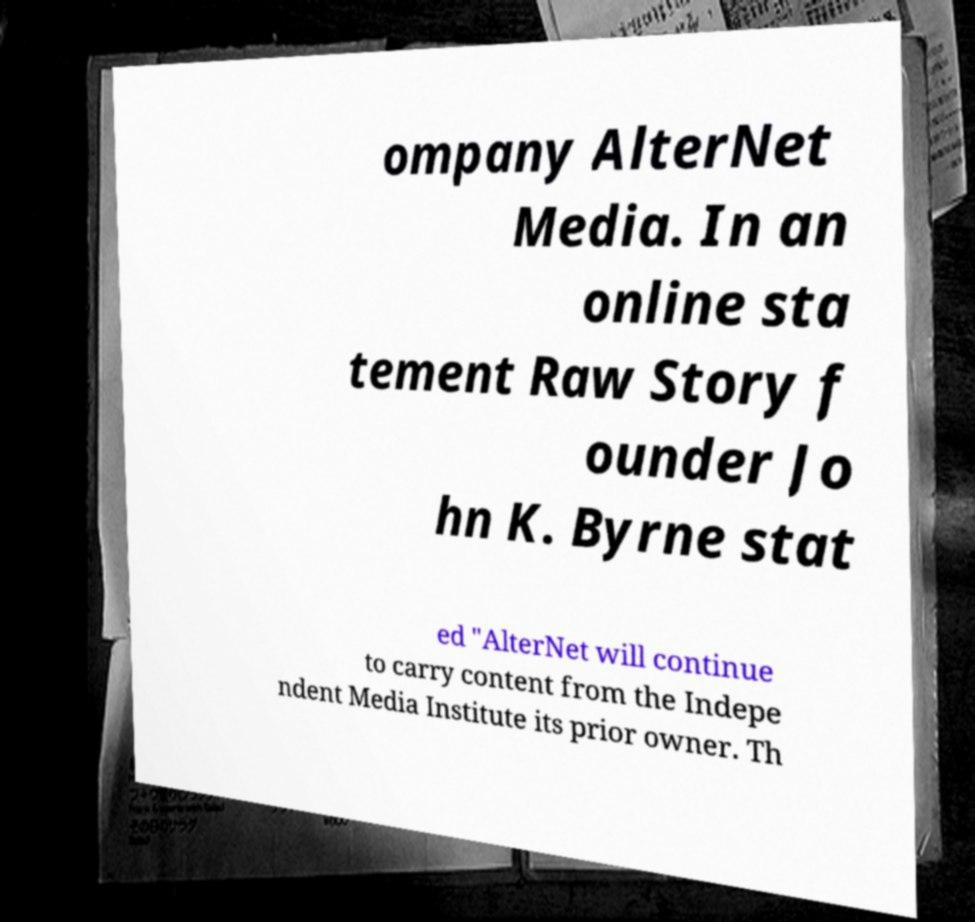There's text embedded in this image that I need extracted. Can you transcribe it verbatim? ompany AlterNet Media. In an online sta tement Raw Story f ounder Jo hn K. Byrne stat ed "AlterNet will continue to carry content from the Indepe ndent Media Institute its prior owner. Th 